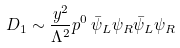Convert formula to latex. <formula><loc_0><loc_0><loc_500><loc_500>D _ { 1 } \sim \frac { y ^ { 2 } } { \Lambda ^ { 2 } } p ^ { 0 } \, \bar { \psi } _ { L } \psi _ { R } \bar { \psi } _ { L } \psi _ { R }</formula> 